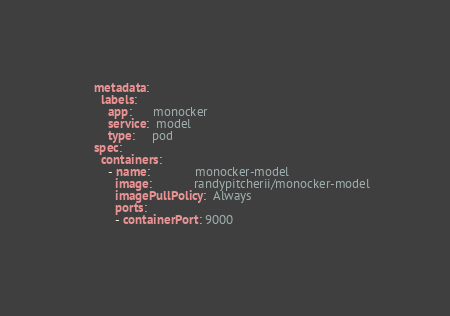<code> <loc_0><loc_0><loc_500><loc_500><_YAML_>    metadata:
      labels:
        app:      monocker
        service:  model
        type:     pod
    spec:
      containers:
        - name:             monocker-model
          image:            randypitcherii/monocker-model
          imagePullPolicy:  Always
          ports:
          - containerPort: 9000
      </code> 